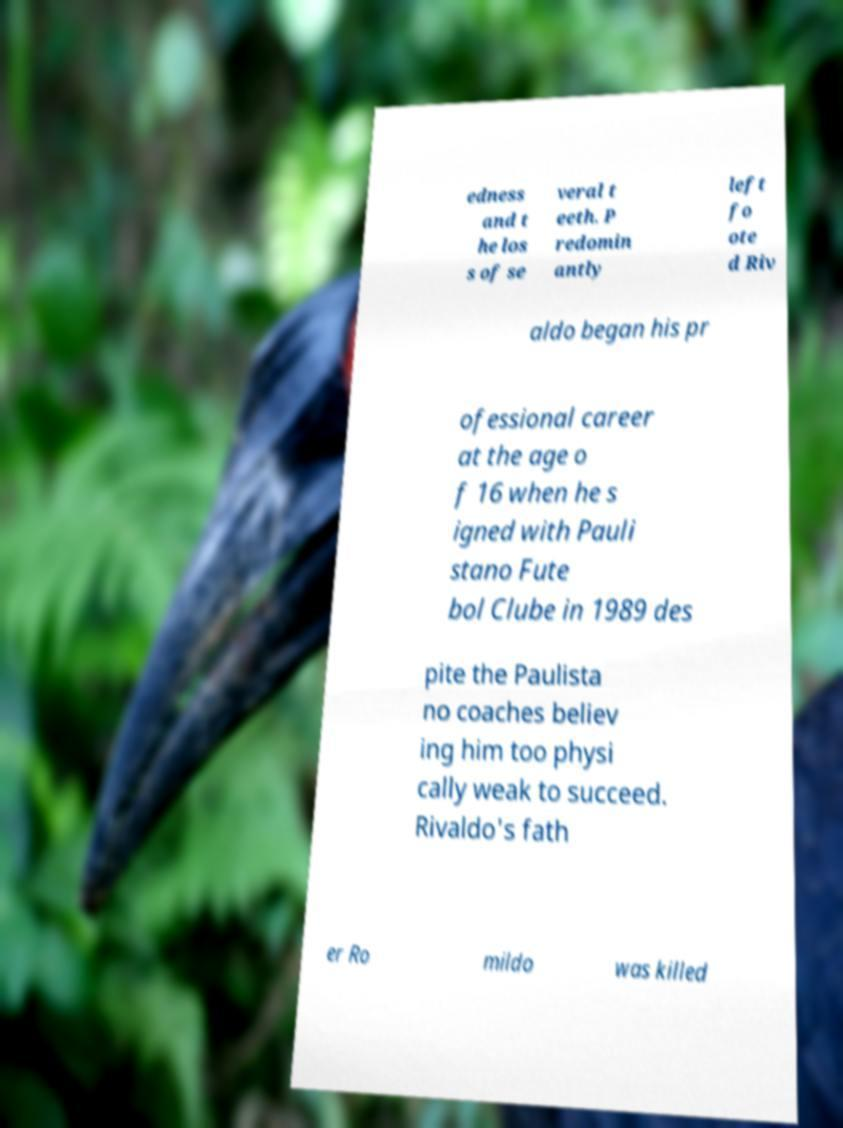For documentation purposes, I need the text within this image transcribed. Could you provide that? edness and t he los s of se veral t eeth. P redomin antly left fo ote d Riv aldo began his pr ofessional career at the age o f 16 when he s igned with Pauli stano Fute bol Clube in 1989 des pite the Paulista no coaches believ ing him too physi cally weak to succeed. Rivaldo's fath er Ro mildo was killed 